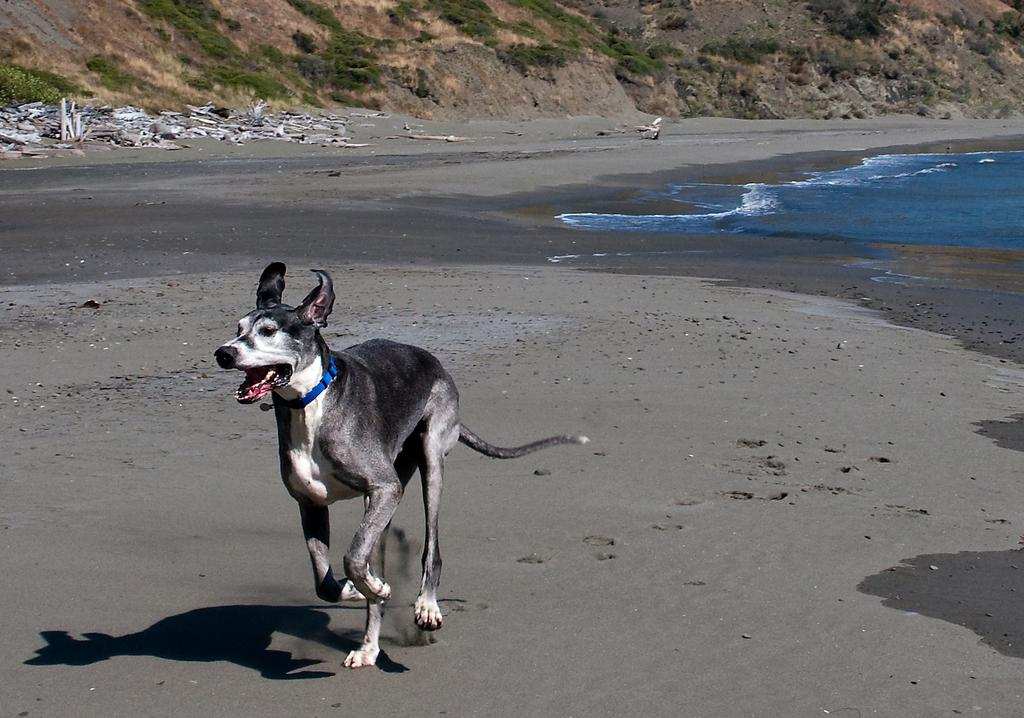What animal can be seen in the image? There is a dog in the image. What is the dog doing in the image? The dog is running on the ground. What type of natural elements are present in the image? There are plants, mountains, water, and dirt visible in the image. What type of cherries can be seen growing on the dog in the image? There are no cherries present in the image, and the dog is not growing any fruits. 